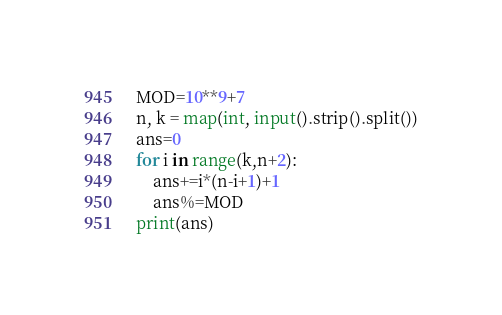Convert code to text. <code><loc_0><loc_0><loc_500><loc_500><_Python_>MOD=10**9+7
n, k = map(int, input().strip().split())
ans=0
for i in range(k,n+2):
    ans+=i*(n-i+1)+1
    ans%=MOD
print(ans)</code> 